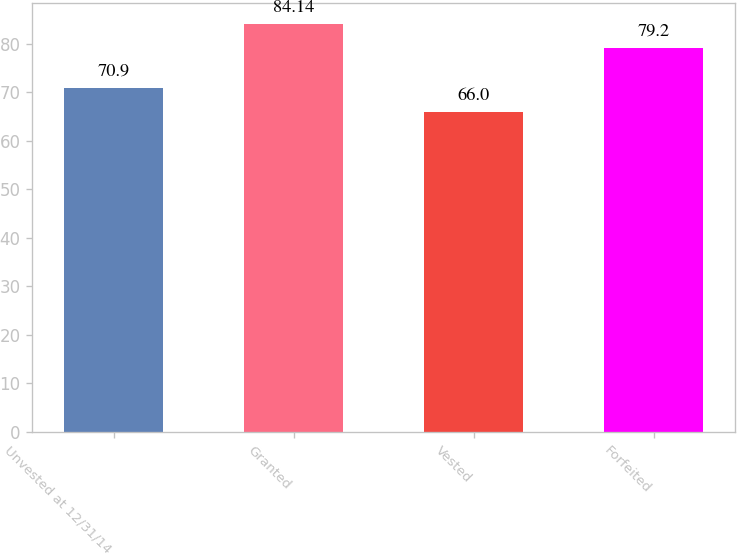Convert chart. <chart><loc_0><loc_0><loc_500><loc_500><bar_chart><fcel>Unvested at 12/31/14<fcel>Granted<fcel>Vested<fcel>Forfeited<nl><fcel>70.9<fcel>84.14<fcel>66<fcel>79.2<nl></chart> 